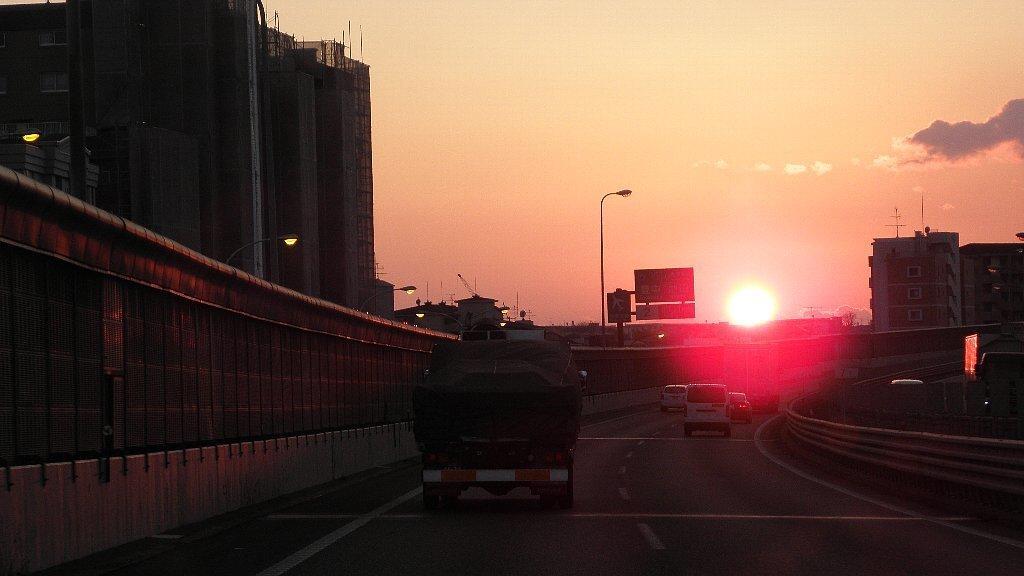In one or two sentences, can you explain what this image depicts? In this image we can see vehicles moving on the road. Here we can see the wall, light poles, boards, buildings, sun and sky with clouds in a background. 